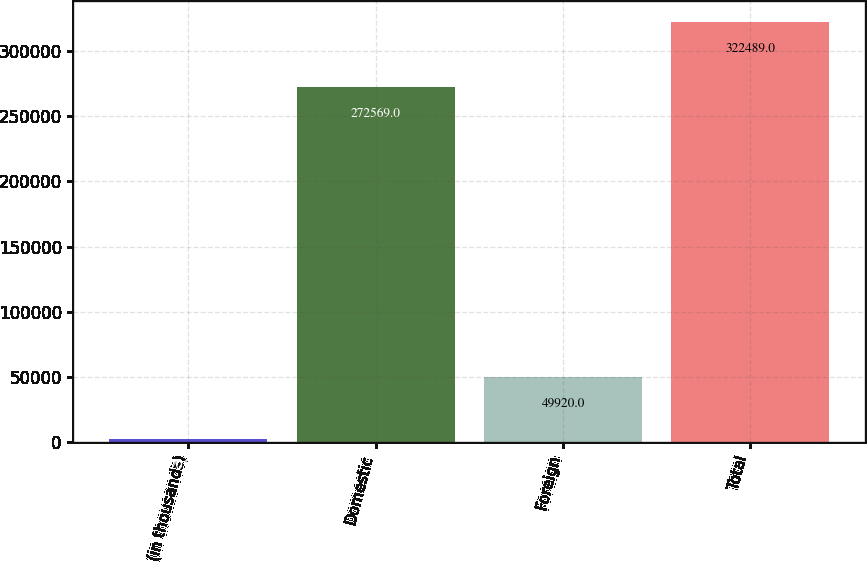<chart> <loc_0><loc_0><loc_500><loc_500><bar_chart><fcel>(in thousands)<fcel>Domestic<fcel>Foreign<fcel>Total<nl><fcel>2013<fcel>272569<fcel>49920<fcel>322489<nl></chart> 